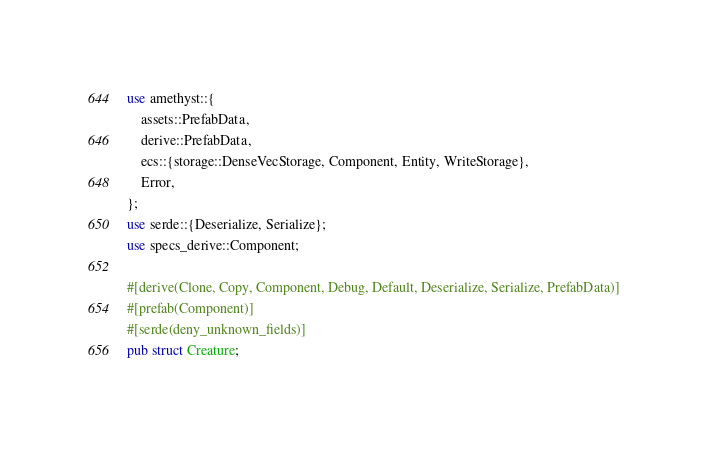<code> <loc_0><loc_0><loc_500><loc_500><_Rust_>use amethyst::{
    assets::PrefabData,
    derive::PrefabData,
    ecs::{storage::DenseVecStorage, Component, Entity, WriteStorage},
    Error,
};
use serde::{Deserialize, Serialize};
use specs_derive::Component;

#[derive(Clone, Copy, Component, Debug, Default, Deserialize, Serialize, PrefabData)]
#[prefab(Component)]
#[serde(deny_unknown_fields)]
pub struct Creature;
</code> 